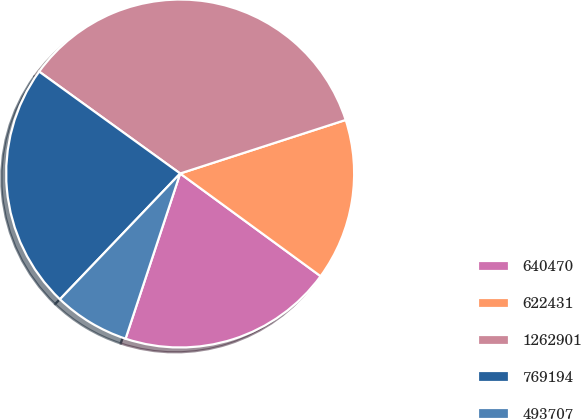<chart> <loc_0><loc_0><loc_500><loc_500><pie_chart><fcel>640470<fcel>622431<fcel>1262901<fcel>769194<fcel>493707<nl><fcel>20.03%<fcel>15.03%<fcel>35.06%<fcel>22.82%<fcel>7.06%<nl></chart> 